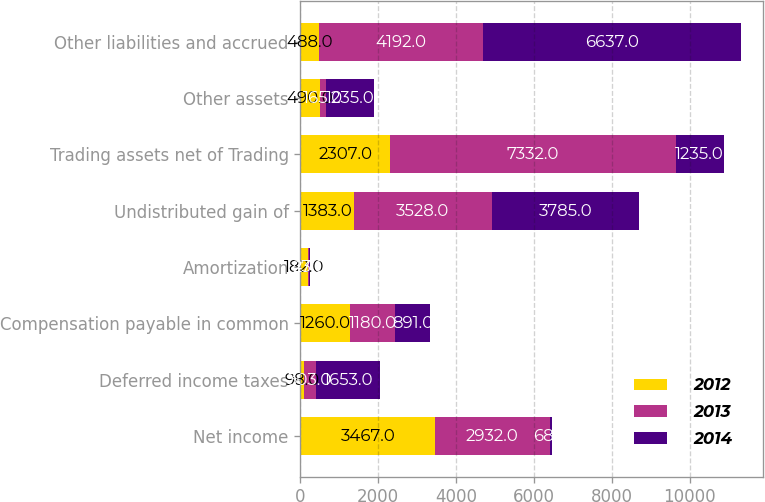<chart> <loc_0><loc_0><loc_500><loc_500><stacked_bar_chart><ecel><fcel>Net income<fcel>Deferred income taxes<fcel>Compensation payable in common<fcel>Amortization<fcel>Undistributed gain of<fcel>Trading assets net of Trading<fcel>Other assets<fcel>Other liabilities and accrued<nl><fcel>2012<fcel>3467<fcel>98<fcel>1260<fcel>182<fcel>1383<fcel>2307<fcel>490<fcel>488<nl><fcel>2013<fcel>2932<fcel>303<fcel>1180<fcel>47<fcel>3528<fcel>7332<fcel>165<fcel>4192<nl><fcel>2014<fcel>68<fcel>1653<fcel>891<fcel>23<fcel>3785<fcel>1235<fcel>1235<fcel>6637<nl></chart> 